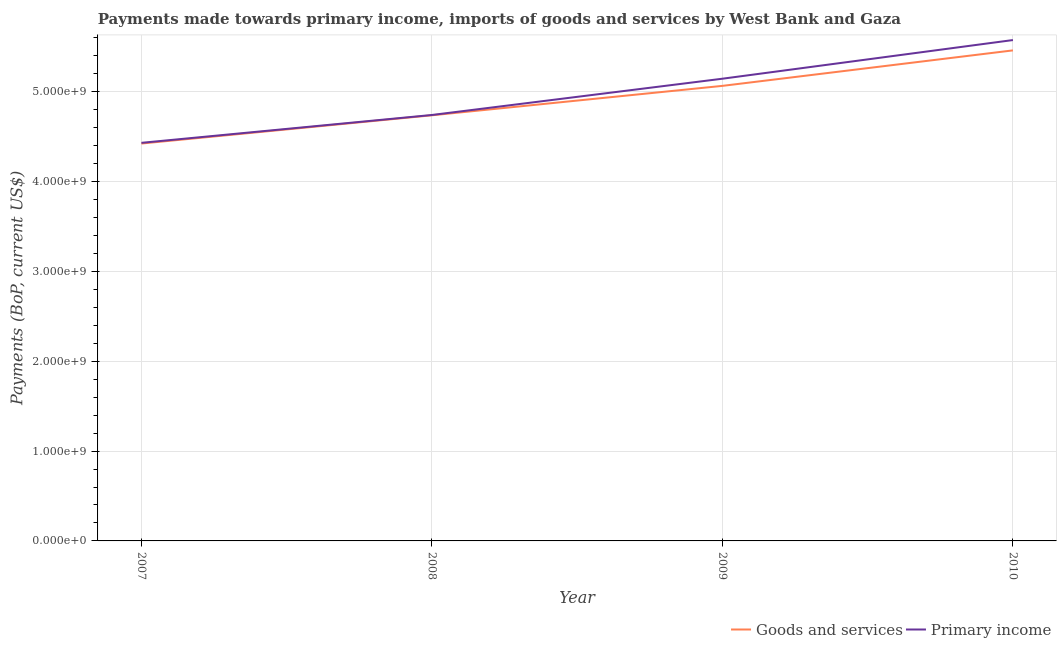How many different coloured lines are there?
Your response must be concise. 2. Does the line corresponding to payments made towards primary income intersect with the line corresponding to payments made towards goods and services?
Give a very brief answer. No. What is the payments made towards primary income in 2010?
Provide a short and direct response. 5.58e+09. Across all years, what is the maximum payments made towards goods and services?
Offer a very short reply. 5.46e+09. Across all years, what is the minimum payments made towards goods and services?
Offer a very short reply. 4.42e+09. What is the total payments made towards goods and services in the graph?
Your response must be concise. 1.97e+1. What is the difference between the payments made towards primary income in 2008 and that in 2009?
Offer a very short reply. -4.04e+08. What is the difference between the payments made towards goods and services in 2009 and the payments made towards primary income in 2007?
Offer a terse response. 6.34e+08. What is the average payments made towards primary income per year?
Offer a very short reply. 4.97e+09. In the year 2007, what is the difference between the payments made towards goods and services and payments made towards primary income?
Offer a very short reply. -7.92e+06. In how many years, is the payments made towards goods and services greater than 4200000000 US$?
Your answer should be compact. 4. What is the ratio of the payments made towards primary income in 2007 to that in 2008?
Offer a very short reply. 0.93. Is the difference between the payments made towards primary income in 2007 and 2008 greater than the difference between the payments made towards goods and services in 2007 and 2008?
Ensure brevity in your answer.  Yes. What is the difference between the highest and the second highest payments made towards primary income?
Provide a succinct answer. 4.30e+08. What is the difference between the highest and the lowest payments made towards goods and services?
Your response must be concise. 1.04e+09. Is the sum of the payments made towards goods and services in 2007 and 2010 greater than the maximum payments made towards primary income across all years?
Provide a short and direct response. Yes. Is the payments made towards goods and services strictly greater than the payments made towards primary income over the years?
Make the answer very short. No. Is the payments made towards goods and services strictly less than the payments made towards primary income over the years?
Provide a short and direct response. Yes. What is the difference between two consecutive major ticks on the Y-axis?
Ensure brevity in your answer.  1.00e+09. Does the graph contain any zero values?
Offer a terse response. No. Does the graph contain grids?
Provide a short and direct response. Yes. Where does the legend appear in the graph?
Your response must be concise. Bottom right. How many legend labels are there?
Keep it short and to the point. 2. What is the title of the graph?
Give a very brief answer. Payments made towards primary income, imports of goods and services by West Bank and Gaza. Does "Tetanus" appear as one of the legend labels in the graph?
Give a very brief answer. No. What is the label or title of the X-axis?
Provide a short and direct response. Year. What is the label or title of the Y-axis?
Give a very brief answer. Payments (BoP, current US$). What is the Payments (BoP, current US$) in Goods and services in 2007?
Your answer should be compact. 4.42e+09. What is the Payments (BoP, current US$) in Primary income in 2007?
Give a very brief answer. 4.43e+09. What is the Payments (BoP, current US$) in Goods and services in 2008?
Your answer should be very brief. 4.74e+09. What is the Payments (BoP, current US$) of Primary income in 2008?
Ensure brevity in your answer.  4.74e+09. What is the Payments (BoP, current US$) in Goods and services in 2009?
Give a very brief answer. 5.07e+09. What is the Payments (BoP, current US$) of Primary income in 2009?
Make the answer very short. 5.15e+09. What is the Payments (BoP, current US$) of Goods and services in 2010?
Ensure brevity in your answer.  5.46e+09. What is the Payments (BoP, current US$) in Primary income in 2010?
Keep it short and to the point. 5.58e+09. Across all years, what is the maximum Payments (BoP, current US$) in Goods and services?
Make the answer very short. 5.46e+09. Across all years, what is the maximum Payments (BoP, current US$) of Primary income?
Give a very brief answer. 5.58e+09. Across all years, what is the minimum Payments (BoP, current US$) in Goods and services?
Make the answer very short. 4.42e+09. Across all years, what is the minimum Payments (BoP, current US$) in Primary income?
Provide a short and direct response. 4.43e+09. What is the total Payments (BoP, current US$) of Goods and services in the graph?
Make the answer very short. 1.97e+1. What is the total Payments (BoP, current US$) in Primary income in the graph?
Offer a very short reply. 1.99e+1. What is the difference between the Payments (BoP, current US$) of Goods and services in 2007 and that in 2008?
Offer a very short reply. -3.15e+08. What is the difference between the Payments (BoP, current US$) in Primary income in 2007 and that in 2008?
Your answer should be very brief. -3.10e+08. What is the difference between the Payments (BoP, current US$) in Goods and services in 2007 and that in 2009?
Keep it short and to the point. -6.42e+08. What is the difference between the Payments (BoP, current US$) in Primary income in 2007 and that in 2009?
Your answer should be very brief. -7.14e+08. What is the difference between the Payments (BoP, current US$) in Goods and services in 2007 and that in 2010?
Ensure brevity in your answer.  -1.04e+09. What is the difference between the Payments (BoP, current US$) in Primary income in 2007 and that in 2010?
Keep it short and to the point. -1.14e+09. What is the difference between the Payments (BoP, current US$) in Goods and services in 2008 and that in 2009?
Your answer should be very brief. -3.28e+08. What is the difference between the Payments (BoP, current US$) of Primary income in 2008 and that in 2009?
Your answer should be compact. -4.04e+08. What is the difference between the Payments (BoP, current US$) in Goods and services in 2008 and that in 2010?
Your response must be concise. -7.23e+08. What is the difference between the Payments (BoP, current US$) in Primary income in 2008 and that in 2010?
Give a very brief answer. -8.34e+08. What is the difference between the Payments (BoP, current US$) in Goods and services in 2009 and that in 2010?
Your response must be concise. -3.95e+08. What is the difference between the Payments (BoP, current US$) in Primary income in 2009 and that in 2010?
Give a very brief answer. -4.30e+08. What is the difference between the Payments (BoP, current US$) of Goods and services in 2007 and the Payments (BoP, current US$) of Primary income in 2008?
Ensure brevity in your answer.  -3.18e+08. What is the difference between the Payments (BoP, current US$) of Goods and services in 2007 and the Payments (BoP, current US$) of Primary income in 2009?
Provide a succinct answer. -7.22e+08. What is the difference between the Payments (BoP, current US$) in Goods and services in 2007 and the Payments (BoP, current US$) in Primary income in 2010?
Make the answer very short. -1.15e+09. What is the difference between the Payments (BoP, current US$) of Goods and services in 2008 and the Payments (BoP, current US$) of Primary income in 2009?
Keep it short and to the point. -4.07e+08. What is the difference between the Payments (BoP, current US$) in Goods and services in 2008 and the Payments (BoP, current US$) in Primary income in 2010?
Your answer should be compact. -8.38e+08. What is the difference between the Payments (BoP, current US$) of Goods and services in 2009 and the Payments (BoP, current US$) of Primary income in 2010?
Provide a short and direct response. -5.10e+08. What is the average Payments (BoP, current US$) of Goods and services per year?
Your answer should be compact. 4.92e+09. What is the average Payments (BoP, current US$) of Primary income per year?
Your response must be concise. 4.97e+09. In the year 2007, what is the difference between the Payments (BoP, current US$) in Goods and services and Payments (BoP, current US$) in Primary income?
Your response must be concise. -7.92e+06. In the year 2008, what is the difference between the Payments (BoP, current US$) in Goods and services and Payments (BoP, current US$) in Primary income?
Your answer should be compact. -3.38e+06. In the year 2009, what is the difference between the Payments (BoP, current US$) in Goods and services and Payments (BoP, current US$) in Primary income?
Make the answer very short. -7.97e+07. In the year 2010, what is the difference between the Payments (BoP, current US$) of Goods and services and Payments (BoP, current US$) of Primary income?
Ensure brevity in your answer.  -1.15e+08. What is the ratio of the Payments (BoP, current US$) of Goods and services in 2007 to that in 2008?
Give a very brief answer. 0.93. What is the ratio of the Payments (BoP, current US$) in Primary income in 2007 to that in 2008?
Make the answer very short. 0.93. What is the ratio of the Payments (BoP, current US$) in Goods and services in 2007 to that in 2009?
Offer a very short reply. 0.87. What is the ratio of the Payments (BoP, current US$) of Primary income in 2007 to that in 2009?
Your response must be concise. 0.86. What is the ratio of the Payments (BoP, current US$) of Goods and services in 2007 to that in 2010?
Make the answer very short. 0.81. What is the ratio of the Payments (BoP, current US$) of Primary income in 2007 to that in 2010?
Provide a succinct answer. 0.79. What is the ratio of the Payments (BoP, current US$) of Goods and services in 2008 to that in 2009?
Your answer should be very brief. 0.94. What is the ratio of the Payments (BoP, current US$) in Primary income in 2008 to that in 2009?
Provide a short and direct response. 0.92. What is the ratio of the Payments (BoP, current US$) in Goods and services in 2008 to that in 2010?
Your response must be concise. 0.87. What is the ratio of the Payments (BoP, current US$) of Primary income in 2008 to that in 2010?
Provide a short and direct response. 0.85. What is the ratio of the Payments (BoP, current US$) in Goods and services in 2009 to that in 2010?
Offer a terse response. 0.93. What is the ratio of the Payments (BoP, current US$) in Primary income in 2009 to that in 2010?
Your answer should be compact. 0.92. What is the difference between the highest and the second highest Payments (BoP, current US$) in Goods and services?
Your response must be concise. 3.95e+08. What is the difference between the highest and the second highest Payments (BoP, current US$) in Primary income?
Offer a terse response. 4.30e+08. What is the difference between the highest and the lowest Payments (BoP, current US$) in Goods and services?
Offer a terse response. 1.04e+09. What is the difference between the highest and the lowest Payments (BoP, current US$) in Primary income?
Your answer should be compact. 1.14e+09. 